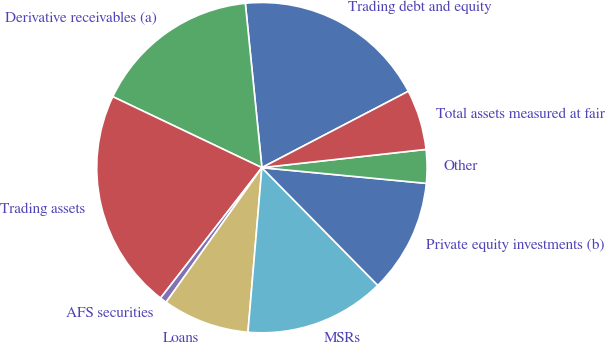<chart> <loc_0><loc_0><loc_500><loc_500><pie_chart><fcel>Trading debt and equity<fcel>Derivative receivables (a)<fcel>Trading assets<fcel>AFS securities<fcel>Loans<fcel>MSRs<fcel>Private equity investments (b)<fcel>Other<fcel>Total assets measured at fair<nl><fcel>18.95%<fcel>16.33%<fcel>21.56%<fcel>0.67%<fcel>8.5%<fcel>13.72%<fcel>11.11%<fcel>3.28%<fcel>5.89%<nl></chart> 